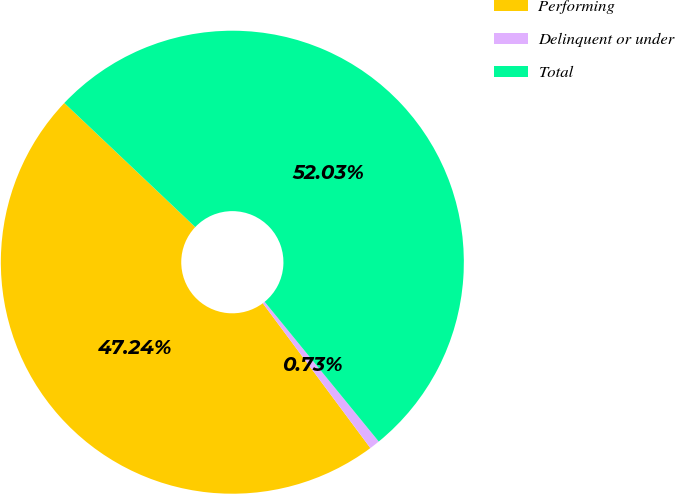<chart> <loc_0><loc_0><loc_500><loc_500><pie_chart><fcel>Performing<fcel>Delinquent or under<fcel>Total<nl><fcel>47.24%<fcel>0.73%<fcel>52.03%<nl></chart> 